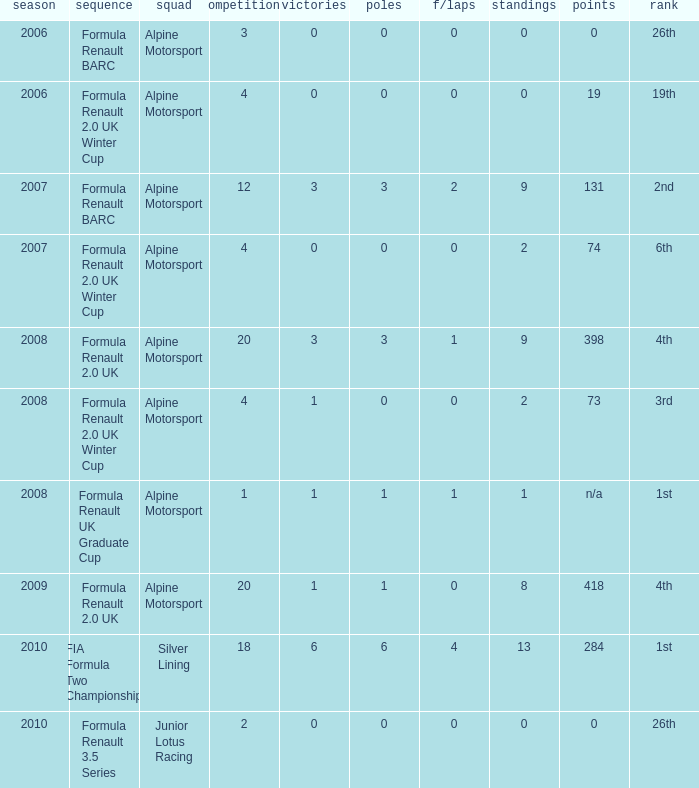What was the earliest season where podium was 9? 2007.0. 